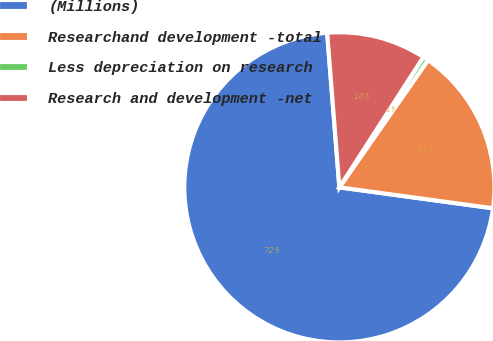<chart> <loc_0><loc_0><loc_500><loc_500><pie_chart><fcel>(Millions)<fcel>Researchand development -total<fcel>Less depreciation on research<fcel>Research and development -net<nl><fcel>71.59%<fcel>17.47%<fcel>0.57%<fcel>10.37%<nl></chart> 